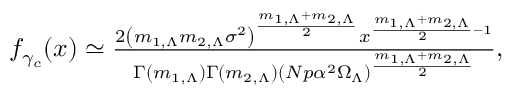Convert formula to latex. <formula><loc_0><loc_0><loc_500><loc_500>\begin{array} { r } { f _ { \gamma _ { c } } ( x ) \simeq \frac { 2 \left ( m _ { 1 , \Lambda } m _ { 2 , \Lambda } \sigma ^ { 2 } \right ) ^ { \frac { m _ { 1 , \Lambda } + m _ { 2 , \Lambda } } { 2 } } x ^ { \frac { m _ { 1 , \Lambda } + m _ { 2 , \Lambda } } { 2 } - 1 } } { \Gamma ( m _ { 1 , \Lambda } ) \Gamma ( m _ { 2 , \Lambda } ) ( N p \alpha ^ { 2 } \Omega _ { \Lambda } ) ^ { \frac { m _ { 1 , \Lambda } + m _ { 2 , \Lambda } } { 2 } } } , } \end{array}</formula> 